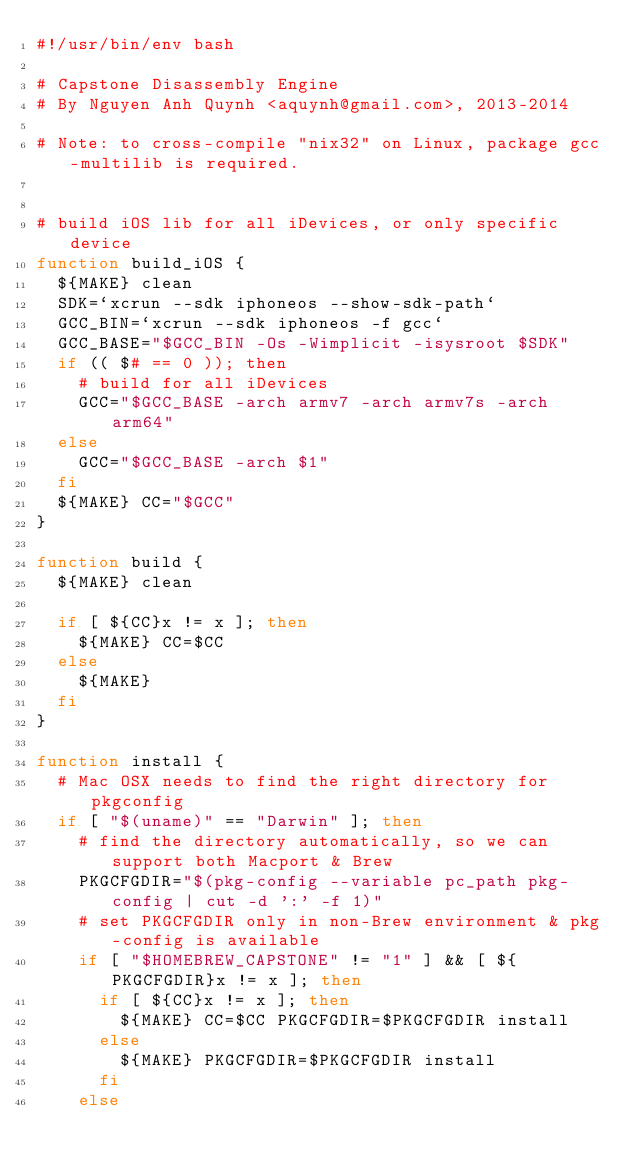<code> <loc_0><loc_0><loc_500><loc_500><_Bash_>#!/usr/bin/env bash

# Capstone Disassembly Engine
# By Nguyen Anh Quynh <aquynh@gmail.com>, 2013-2014

# Note: to cross-compile "nix32" on Linux, package gcc-multilib is required.


# build iOS lib for all iDevices, or only specific device
function build_iOS {
	${MAKE} clean
	SDK=`xcrun --sdk iphoneos --show-sdk-path`
	GCC_BIN=`xcrun --sdk iphoneos -f gcc`
	GCC_BASE="$GCC_BIN -Os -Wimplicit -isysroot $SDK"
	if (( $# == 0 )); then
		# build for all iDevices
		GCC="$GCC_BASE -arch armv7 -arch armv7s -arch arm64"
	else
		GCC="$GCC_BASE -arch $1"
	fi
	${MAKE} CC="$GCC"
}

function build {
	${MAKE} clean

	if [ ${CC}x != x ]; then
		${MAKE} CC=$CC
	else
		${MAKE}
	fi
}

function install {
	# Mac OSX needs to find the right directory for pkgconfig
	if [ "$(uname)" == "Darwin" ]; then
		# find the directory automatically, so we can support both Macport & Brew
		PKGCFGDIR="$(pkg-config --variable pc_path pkg-config | cut -d ':' -f 1)"
		# set PKGCFGDIR only in non-Brew environment & pkg-config is available
		if [ "$HOMEBREW_CAPSTONE" != "1" ] && [ ${PKGCFGDIR}x != x ]; then
			if [ ${CC}x != x ]; then
				${MAKE} CC=$CC PKGCFGDIR=$PKGCFGDIR install
			else
				${MAKE} PKGCFGDIR=$PKGCFGDIR install
			fi
		else</code> 